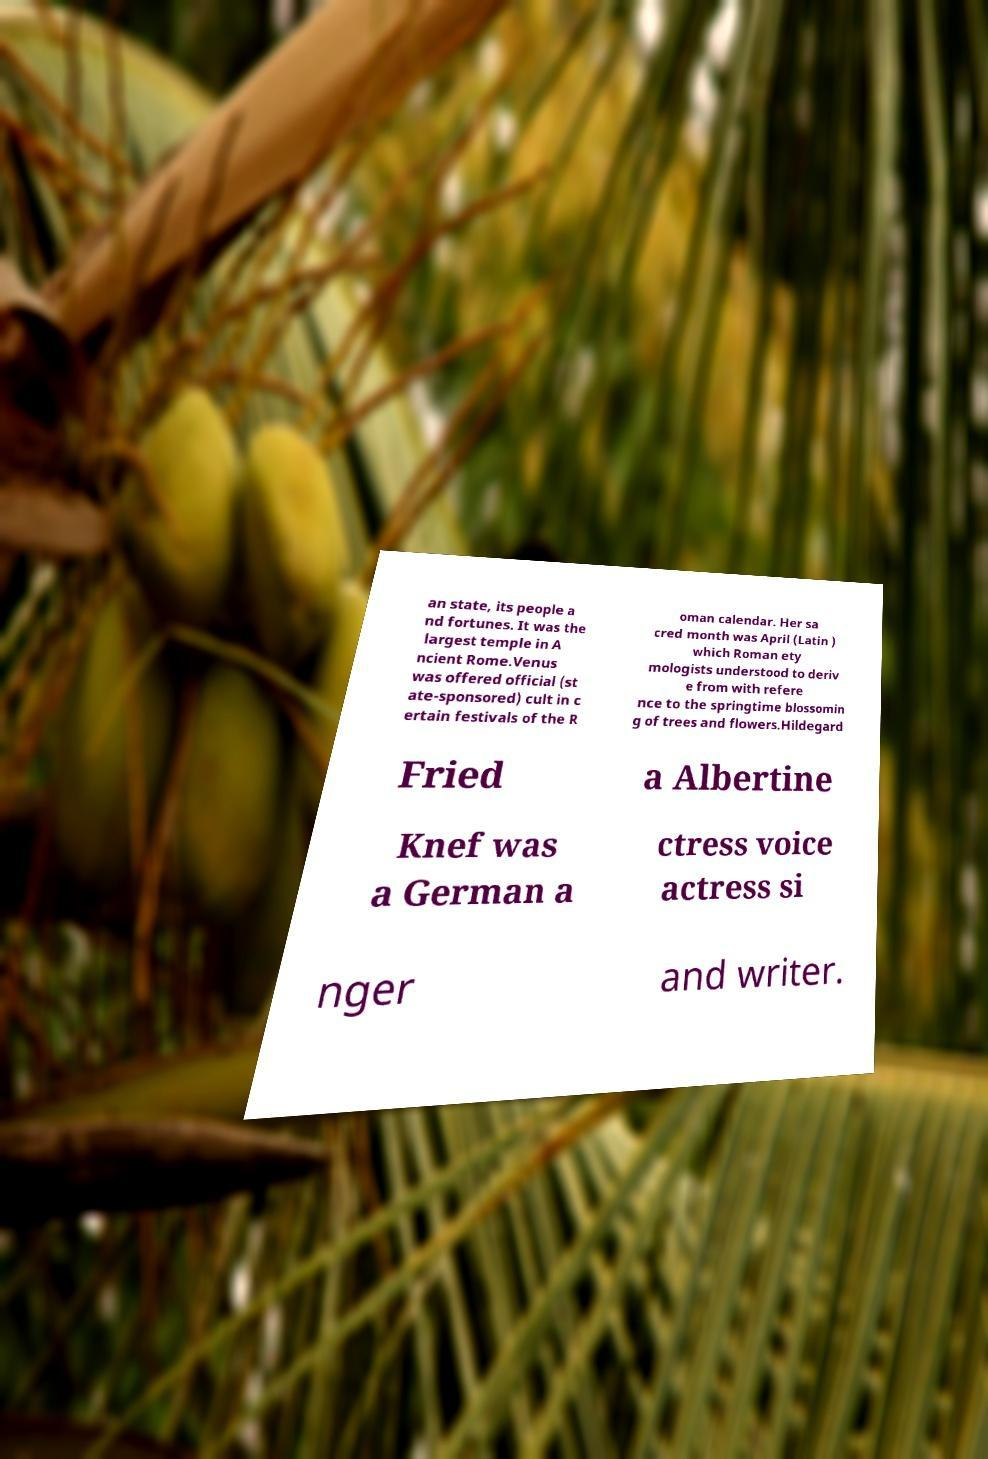For documentation purposes, I need the text within this image transcribed. Could you provide that? an state, its people a nd fortunes. It was the largest temple in A ncient Rome.Venus was offered official (st ate-sponsored) cult in c ertain festivals of the R oman calendar. Her sa cred month was April (Latin ) which Roman ety mologists understood to deriv e from with refere nce to the springtime blossomin g of trees and flowers.Hildegard Fried a Albertine Knef was a German a ctress voice actress si nger and writer. 